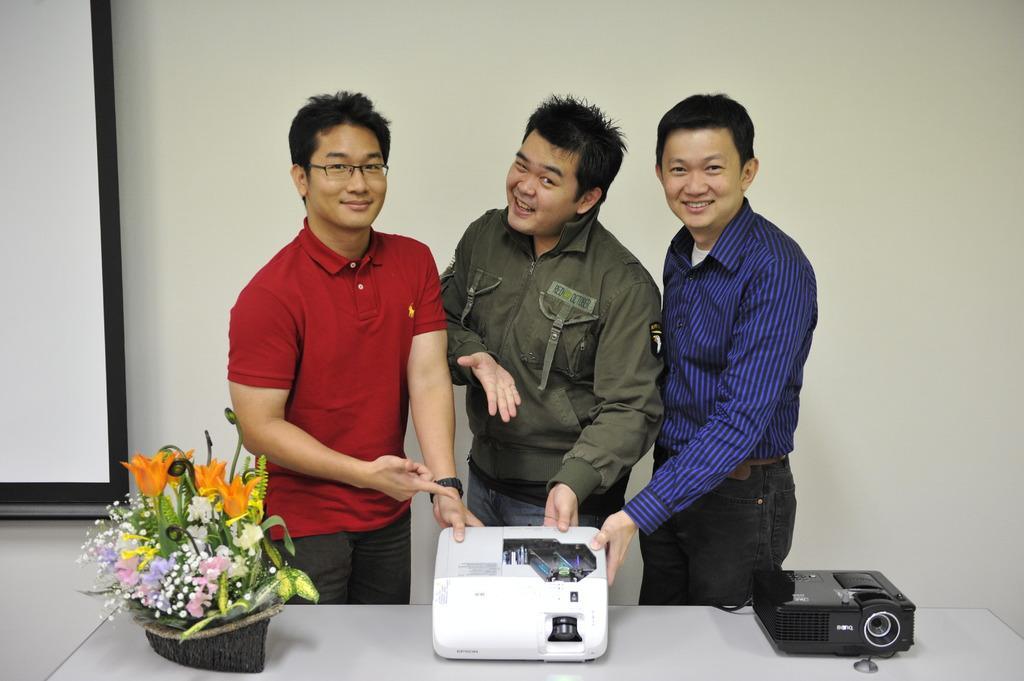In one or two sentences, can you explain what this image depicts? In this picture we can see a projector and some flowers in a boat shaped object on the table. We can see three men holding a device in their hands. There is a projector screen on the left side. We can see a wall in the background. 